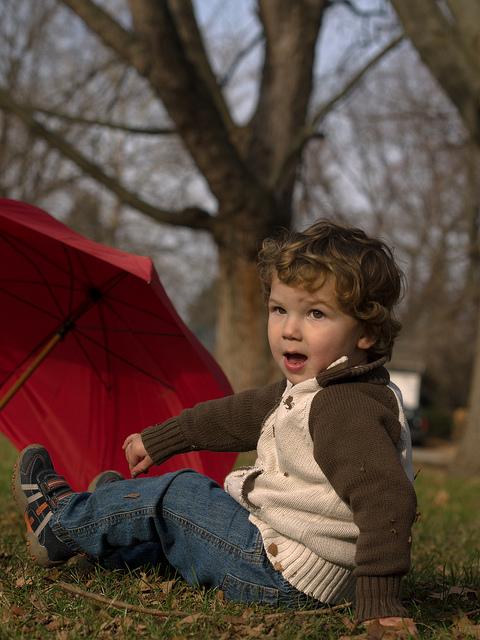Is it raining?
Concise answer only. No. Is the kid wearing jeans?
Short answer required. Yes. Is there a tripod?
Concise answer only. No. Where is the boy sitting?
Keep it brief. Grass. 